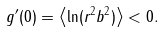Convert formula to latex. <formula><loc_0><loc_0><loc_500><loc_500>g ^ { \prime } ( 0 ) = \left \langle \ln ( r ^ { 2 } b ^ { 2 } ) \right \rangle < 0 .</formula> 